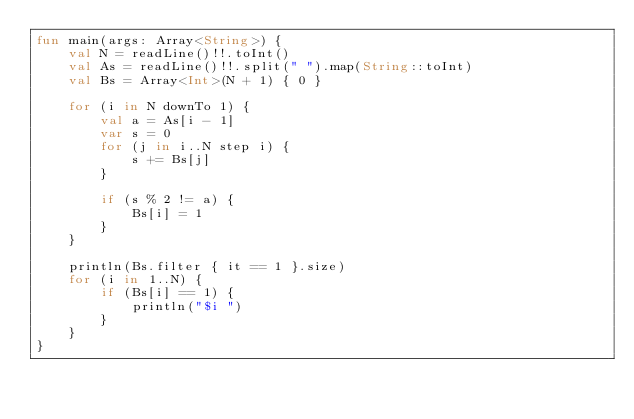<code> <loc_0><loc_0><loc_500><loc_500><_Kotlin_>fun main(args: Array<String>) {
    val N = readLine()!!.toInt()
    val As = readLine()!!.split(" ").map(String::toInt)
    val Bs = Array<Int>(N + 1) { 0 }

    for (i in N downTo 1) {
        val a = As[i - 1]
        var s = 0
        for (j in i..N step i) {
            s += Bs[j]
        }

        if (s % 2 != a) {
            Bs[i] = 1
        }
    }

    println(Bs.filter { it == 1 }.size)
    for (i in 1..N) {
        if (Bs[i] == 1) {
            println("$i ")
        }
    }
}</code> 